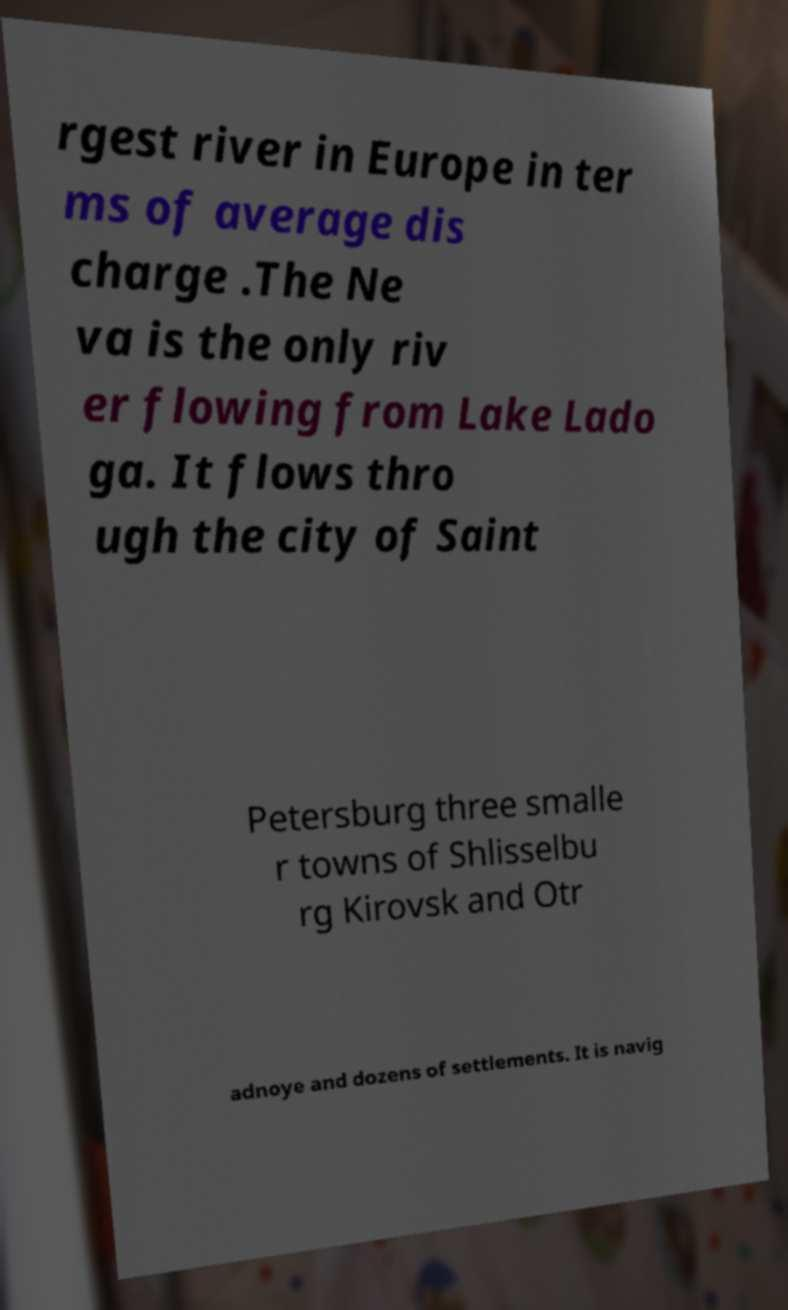Could you extract and type out the text from this image? rgest river in Europe in ter ms of average dis charge .The Ne va is the only riv er flowing from Lake Lado ga. It flows thro ugh the city of Saint Petersburg three smalle r towns of Shlisselbu rg Kirovsk and Otr adnoye and dozens of settlements. It is navig 